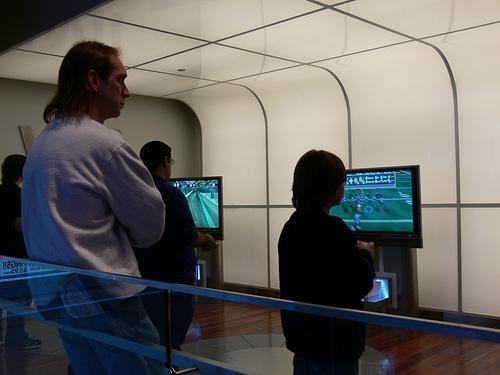How many men in white shirts?
Give a very brief answer. 1. How many televisions are in this photo?
Give a very brief answer. 2. How many tvs are visible?
Give a very brief answer. 2. How many people are visible?
Give a very brief answer. 4. How many yellow umbrellas are in this photo?
Give a very brief answer. 0. 